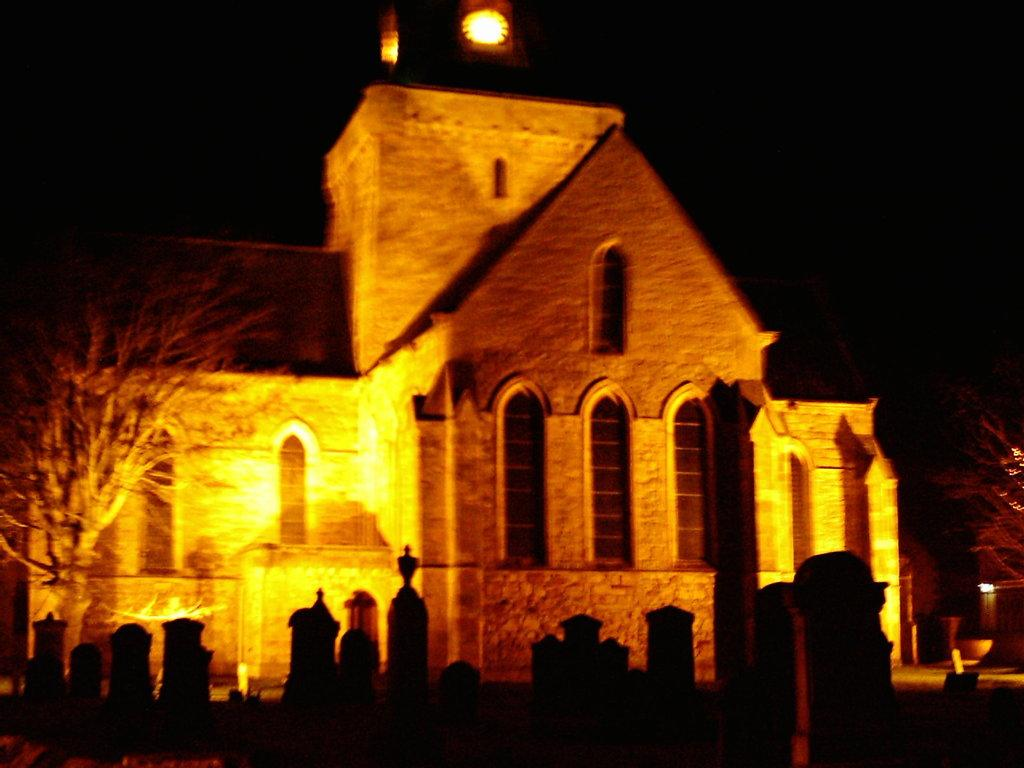What type of structure is present in the image? There is a building in the image. What is located in front of the building? There is a tree in front of the building. What type of objects are present in the image? There are headstones in the image. What town is visible in the background of the image? There is no town visible in the image; it only features a building, a tree, and headstones. How does the experience of looking at the image change over time? The experience of looking at the image does not change over time, as it is a static image. 